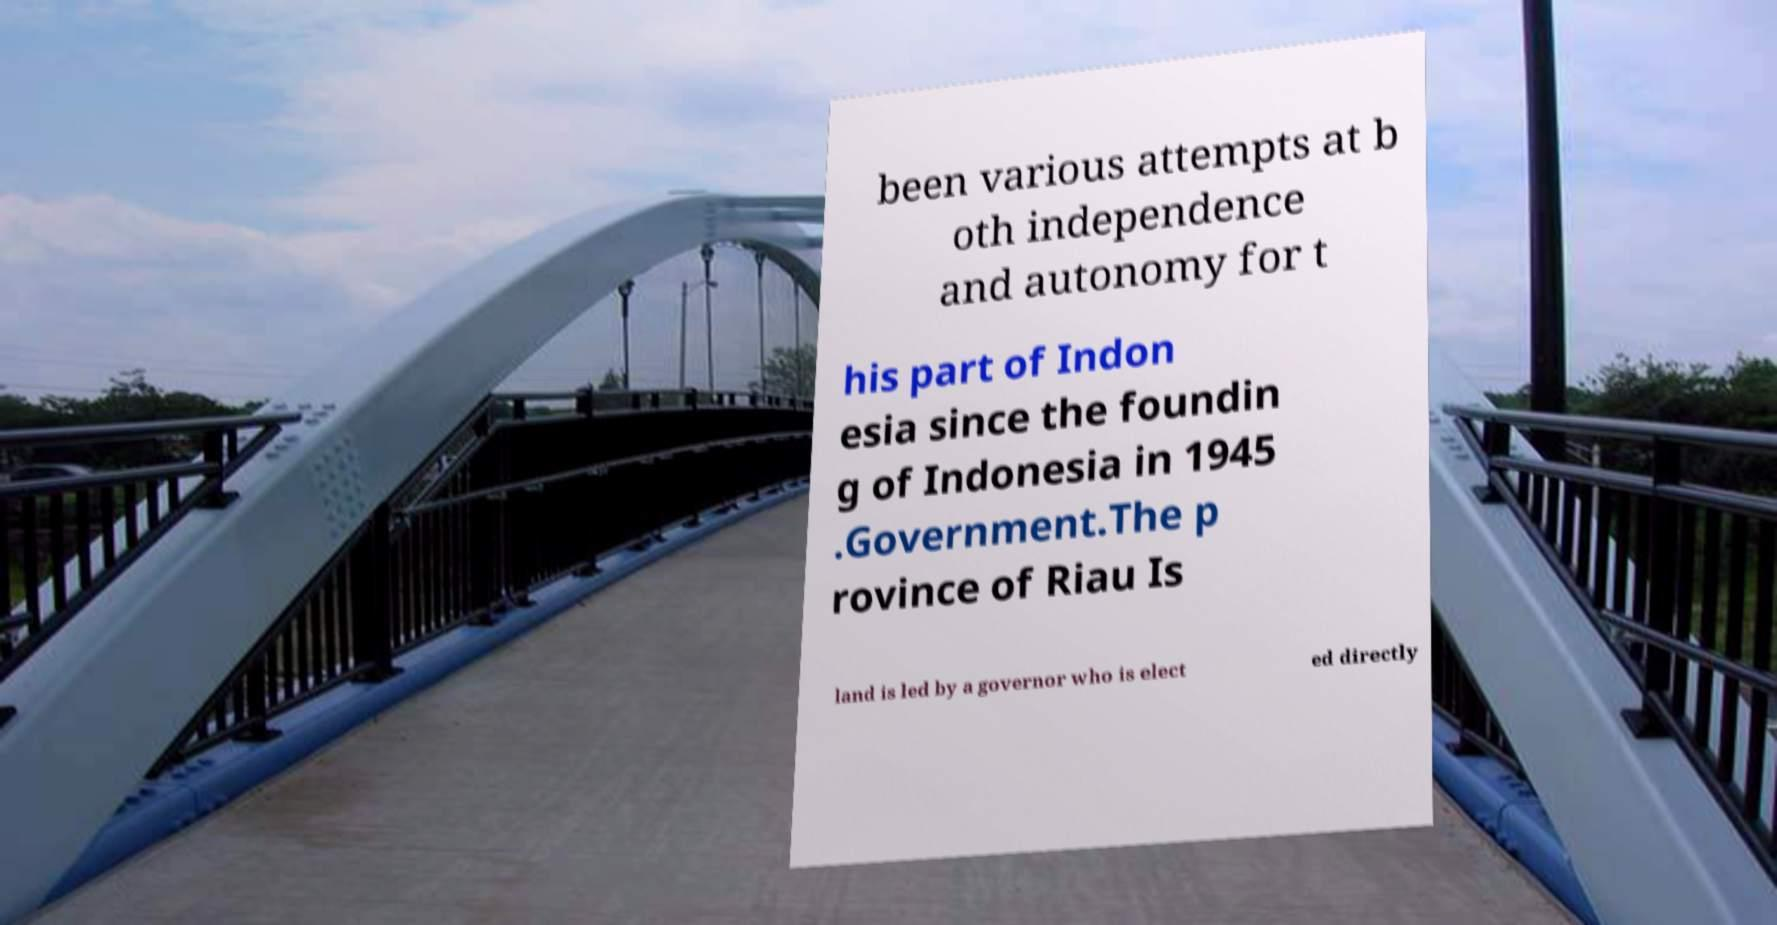For documentation purposes, I need the text within this image transcribed. Could you provide that? been various attempts at b oth independence and autonomy for t his part of Indon esia since the foundin g of Indonesia in 1945 .Government.The p rovince of Riau Is land is led by a governor who is elect ed directly 